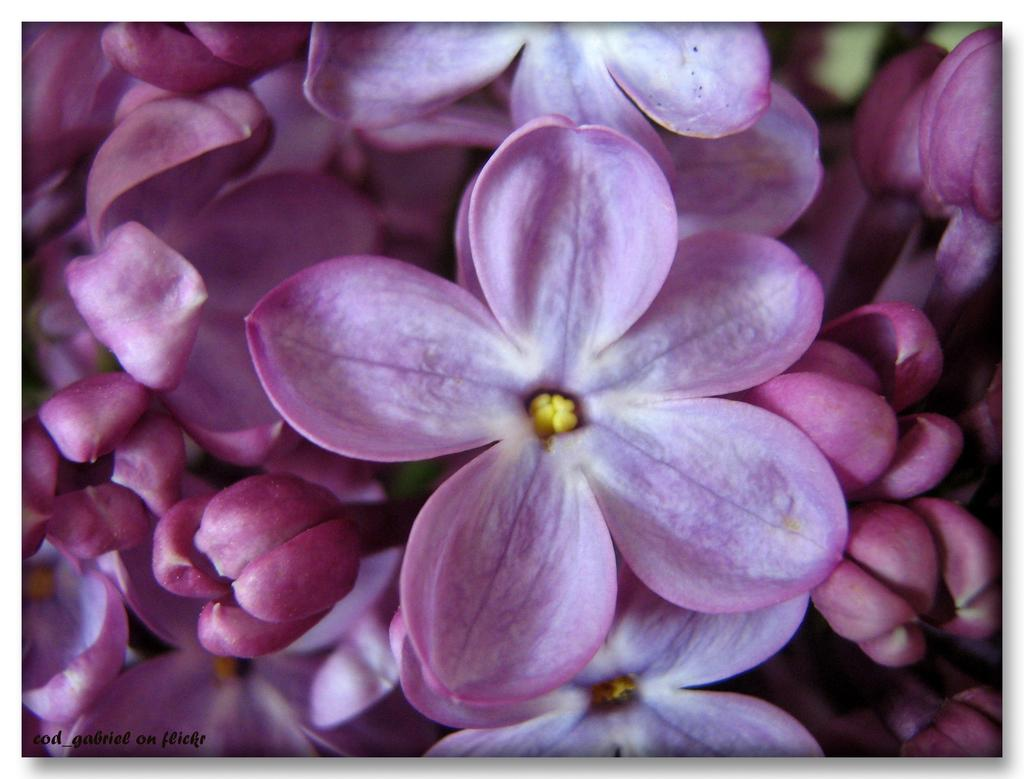What type of plants are in the image? There are flowers in the image. What color are the flowers? The flowers are pink in color. What type of account is being discussed in the image? There is no account being discussed in the image; it features pink flowers. Can you hear the voice of the flowers in the image? There is no voice associated with the flowers in the image, as flowers do not have the ability to speak or make sounds. 